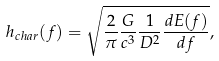Convert formula to latex. <formula><loc_0><loc_0><loc_500><loc_500>h _ { c h a r } ( f ) = \sqrt { \frac { 2 } { \pi } \frac { G } { c ^ { 3 } } \frac { 1 } { D ^ { 2 } } \frac { d E ( f ) } { d f } } ,</formula> 